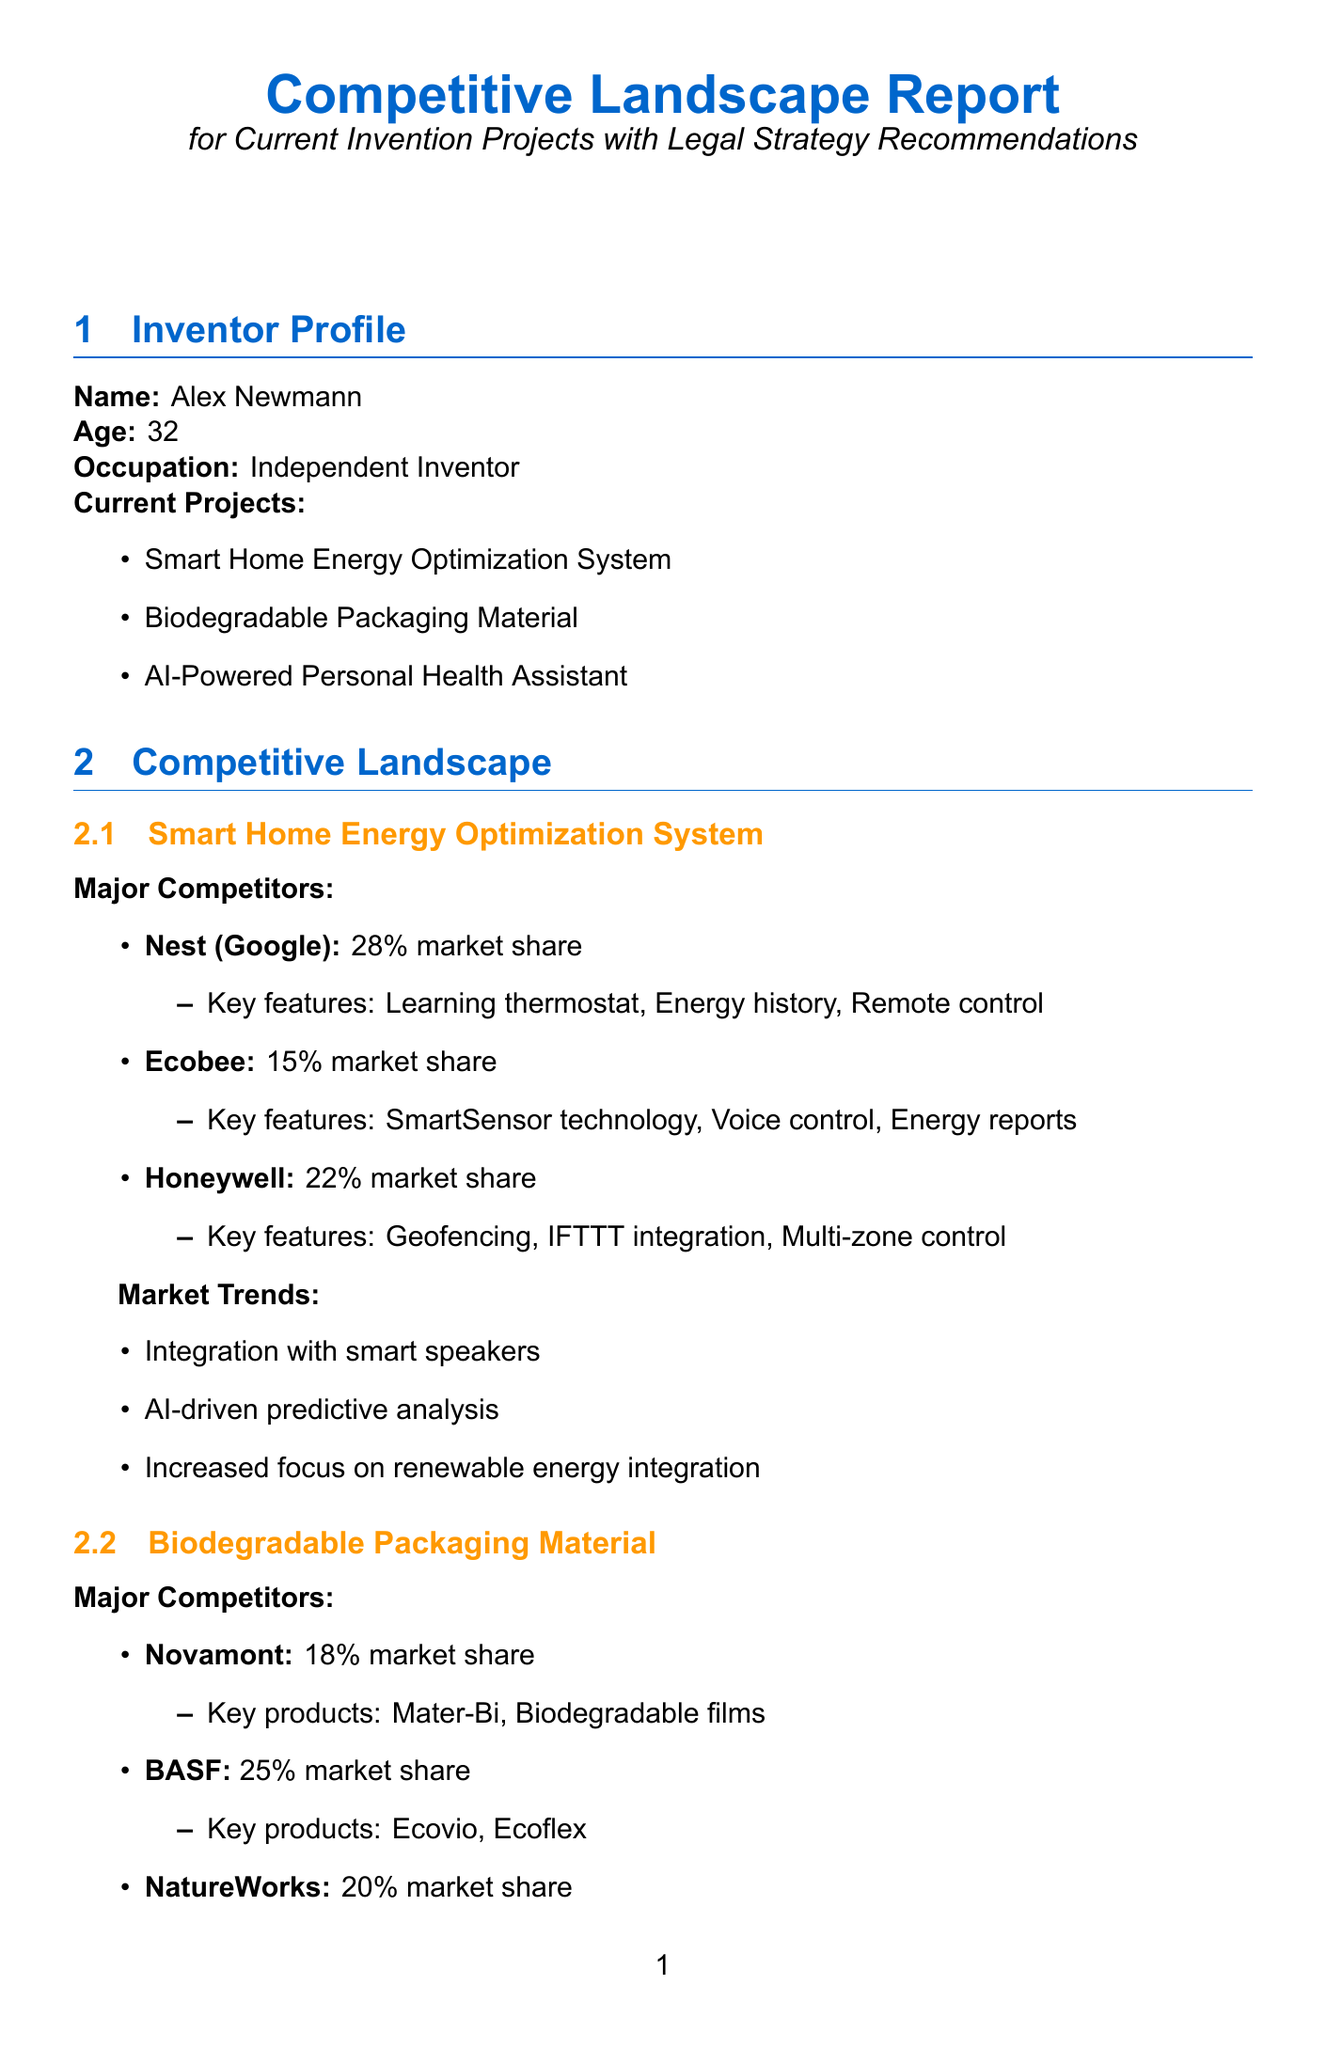what is the name of the inventor? The document states that the inventor's name is Alex Newmann.
Answer: Alex Newmann how many major competitors does the Smart Home Energy Optimization System have? The document lists three major competitors under the Smart Home Energy Optimization System section.
Answer: 3 what is the market share of BASF in the biodegradable packaging market? The document indicates that BASF has a market share of 25%.
Answer: 25% which legal recommendation is suggested for the AI-Powered Personal Health Assistant project? The document recommends prioritizing HIPAA compliance and data security measures as well as other legal strategies.
Answer: Prioritize HIPAA compliance what are the key products of Novamont? The document states that Novamont's key products include Mater-Bi and Biodegradable films.
Answer: Mater-Bi, Biodegradable films who is the recommended potential investor for Green technology and healthcare? The document mentions Kleiner Perkins as the focused investor for Green technology and healthcare.
Answer: Kleiner Perkins what is the relevance of the CES event mentioned in the document? The document notes that CES is relevant for showcasing the Smart Home Energy Optimization System.
Answer: Showcase Smart Home Energy Optimization System how many current projects does Alex Newmann have listed in the document? The document lists three current projects that Alex Newmann is working on.
Answer: 3 which market trend is associated with AI-Powered Personal Health Assistant? The document indicates that one of the market trends is the integration with wearable devices.
Answer: Integration with wearable devices 